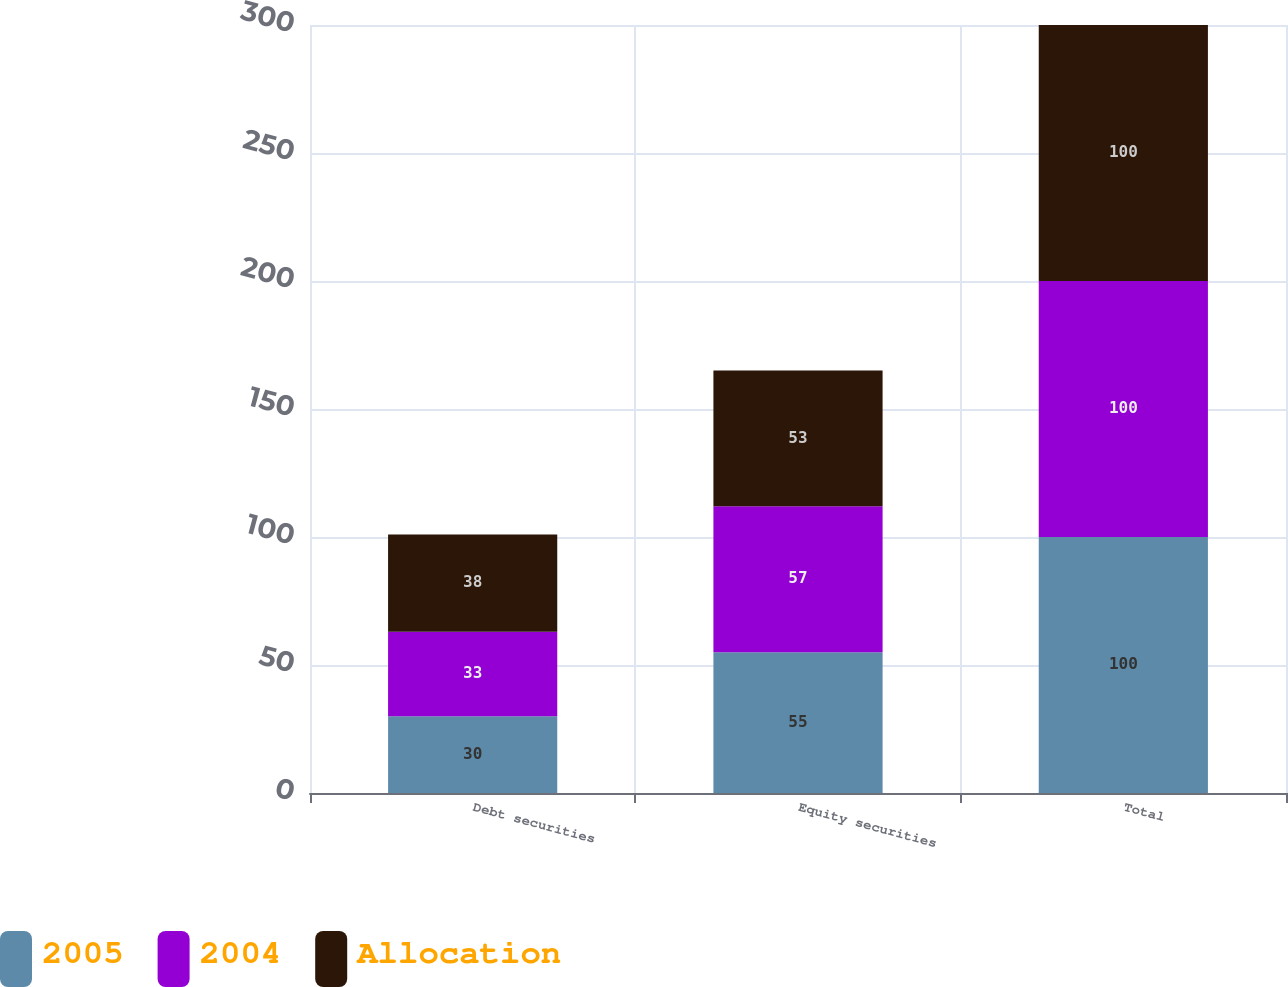Convert chart to OTSL. <chart><loc_0><loc_0><loc_500><loc_500><stacked_bar_chart><ecel><fcel>Debt securities<fcel>Equity securities<fcel>Total<nl><fcel>2005<fcel>30<fcel>55<fcel>100<nl><fcel>2004<fcel>33<fcel>57<fcel>100<nl><fcel>Allocation<fcel>38<fcel>53<fcel>100<nl></chart> 